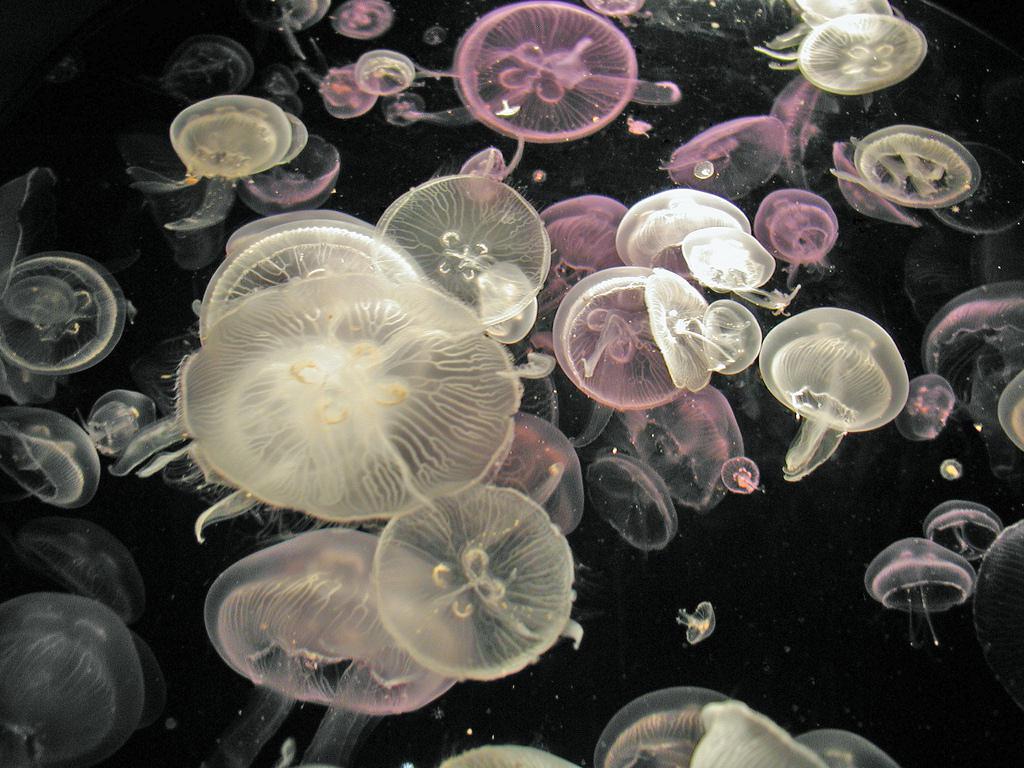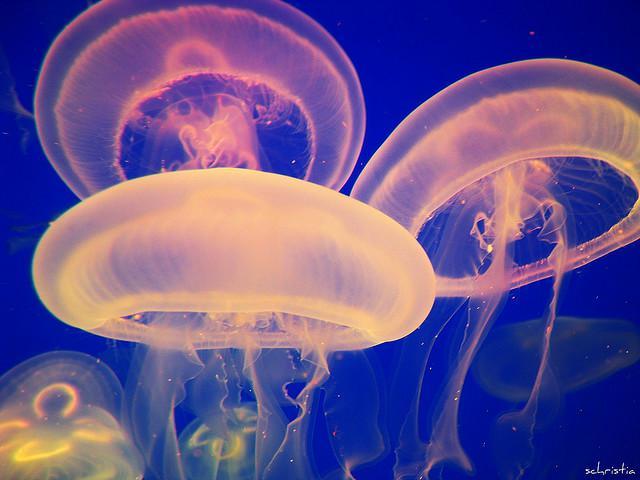The first image is the image on the left, the second image is the image on the right. Considering the images on both sides, is "At least one image shows jellyfish of different colors." valid? Answer yes or no. Yes. 